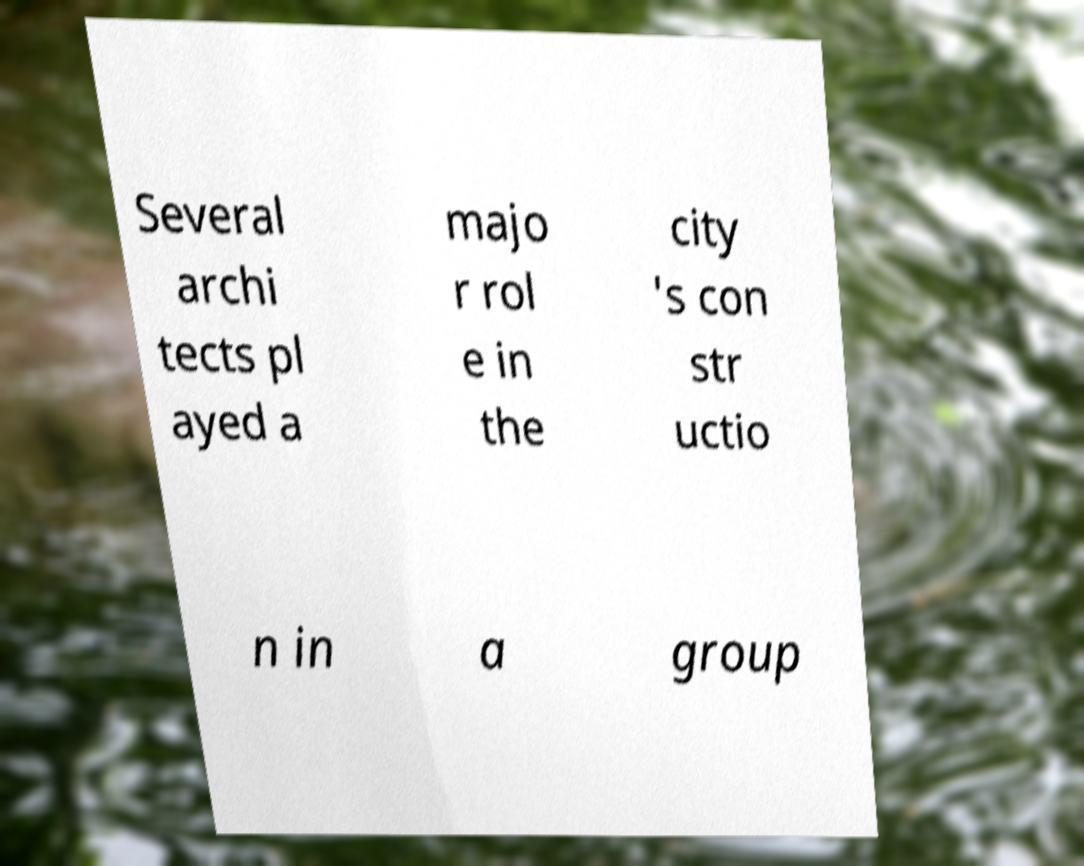Can you accurately transcribe the text from the provided image for me? Several archi tects pl ayed a majo r rol e in the city 's con str uctio n in a group 